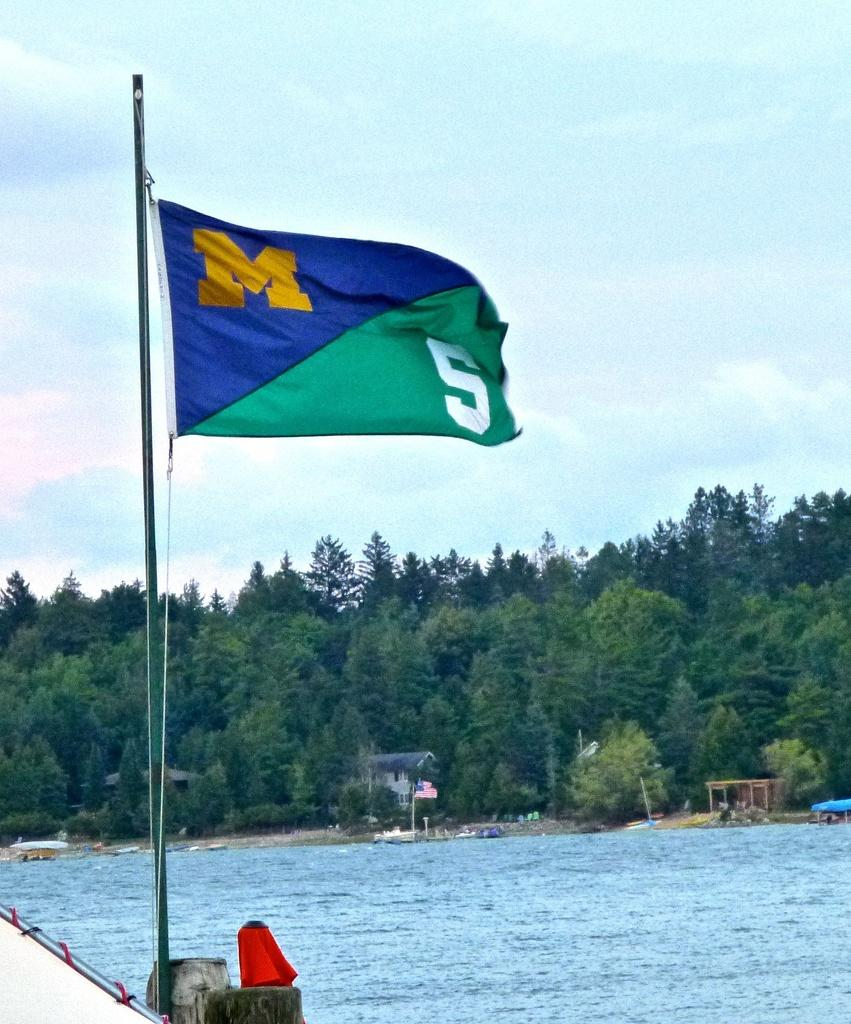What is the main object featured in the image? There is a flag in the image. What natural feature can be seen at the bottom of the image? There is a river at the bottom of the image. What type of vegetation is present in the middle of the image? There are trees in the middle of the image. What part of the natural environment is visible at the top of the image? There is a sky at the top of the image. What type of lunch is being served in the image? There is no lunch present in the image; it features a flag, a river, trees, and a sky. Can you see any ducks swimming in the river in the image? There are no ducks visible in the image; it only shows a flag, a river, trees, and a sky. 